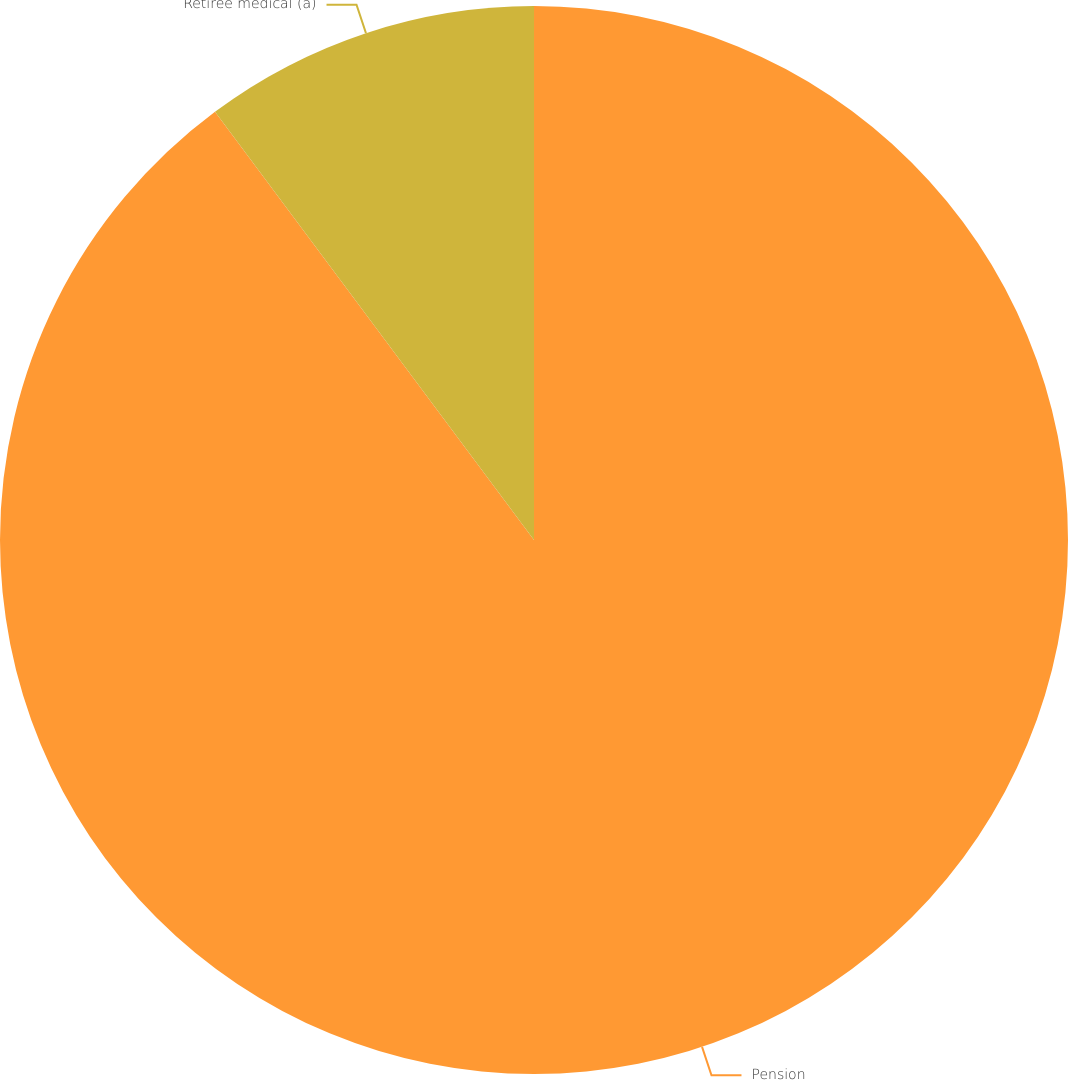Convert chart. <chart><loc_0><loc_0><loc_500><loc_500><pie_chart><fcel>Pension<fcel>Retiree medical (a)<nl><fcel>89.81%<fcel>10.19%<nl></chart> 